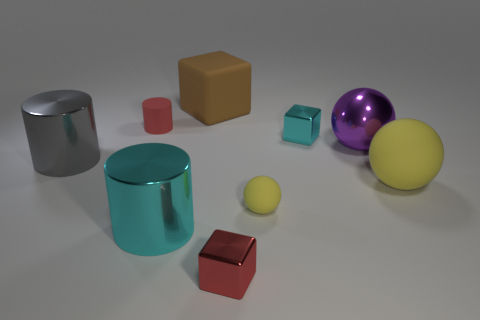Which objects in the image have reflective surfaces? The objects with reflective surfaces in the image are the large silver cylinder, the sphere with a blend of purple and pink colors, and the smaller silver cylinder. How does the lighting in the scene affect these reflective objects? The lighting in the scene enhances the reflective quality of these objects by creating highlights and shadows that define their shapes and textures. The reflective surfaces interact with the light to show off a mirror-like finish, adding depth and realism to the scene. 